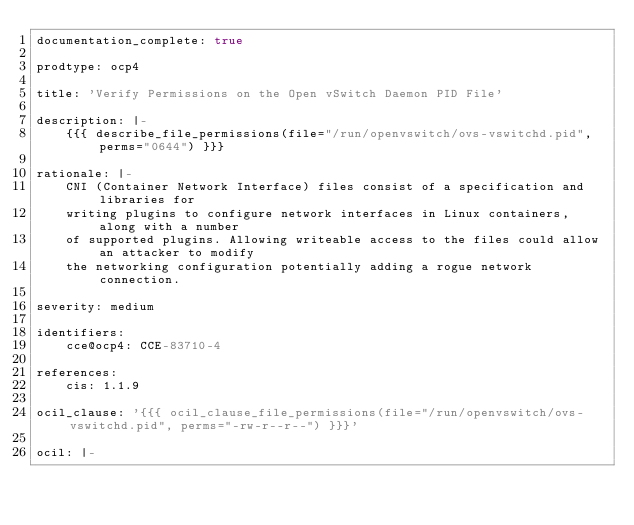Convert code to text. <code><loc_0><loc_0><loc_500><loc_500><_YAML_>documentation_complete: true

prodtype: ocp4

title: 'Verify Permissions on the Open vSwitch Daemon PID File'

description: |-
    {{{ describe_file_permissions(file="/run/openvswitch/ovs-vswitchd.pid", perms="0644") }}}

rationale: |-
    CNI (Container Network Interface) files consist of a specification and libraries for
    writing plugins to configure network interfaces in Linux containers, along with a number
    of supported plugins. Allowing writeable access to the files could allow an attacker to modify
    the networking configuration potentially adding a rogue network connection.

severity: medium

identifiers:
    cce@ocp4: CCE-83710-4

references:
    cis: 1.1.9

ocil_clause: '{{{ ocil_clause_file_permissions(file="/run/openvswitch/ovs-vswitchd.pid", perms="-rw-r--r--") }}}'

ocil: |-</code> 